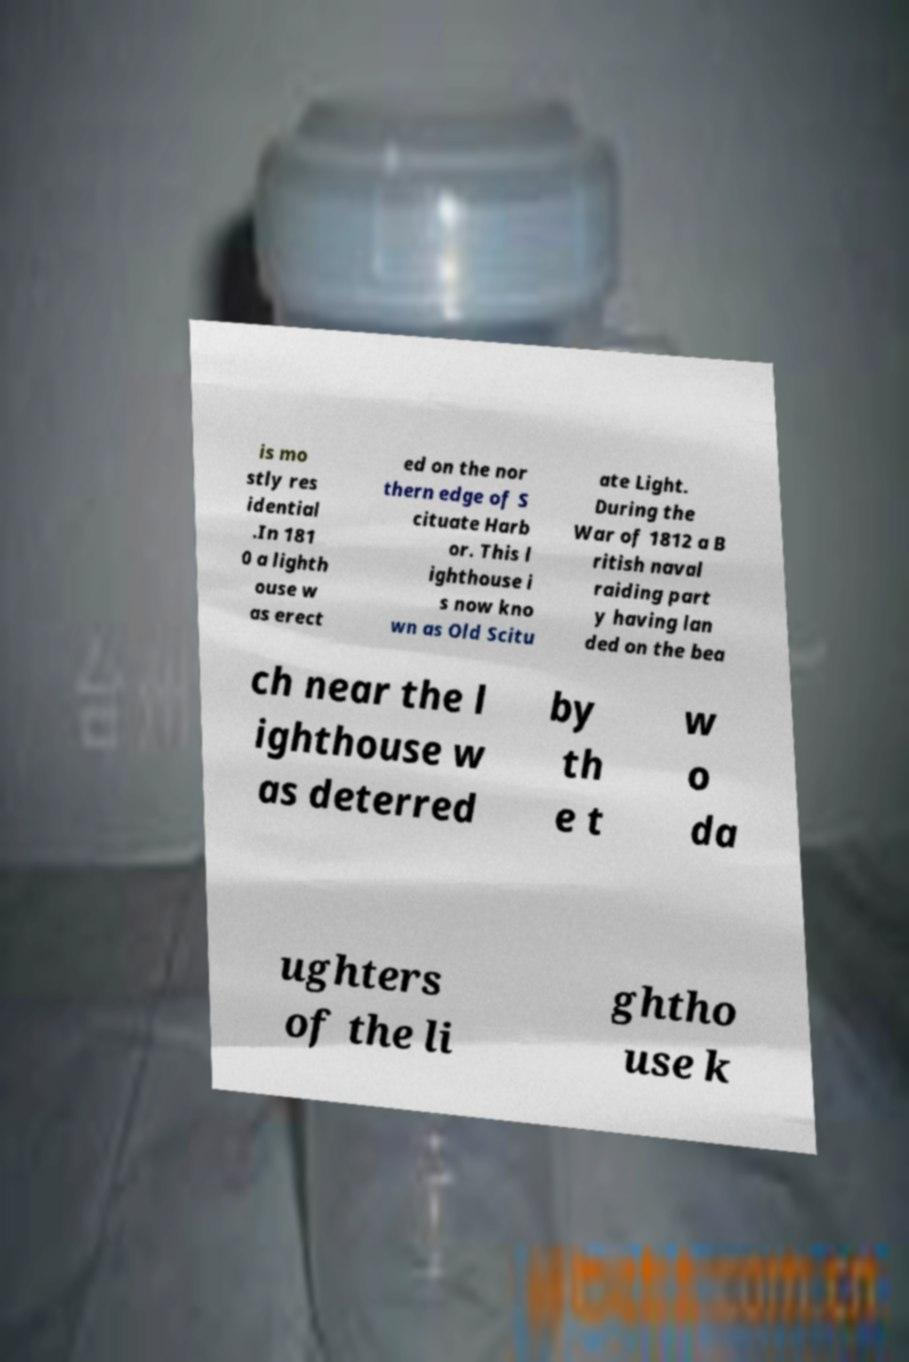Can you accurately transcribe the text from the provided image for me? is mo stly res idential .In 181 0 a lighth ouse w as erect ed on the nor thern edge of S cituate Harb or. This l ighthouse i s now kno wn as Old Scitu ate Light. During the War of 1812 a B ritish naval raiding part y having lan ded on the bea ch near the l ighthouse w as deterred by th e t w o da ughters of the li ghtho use k 